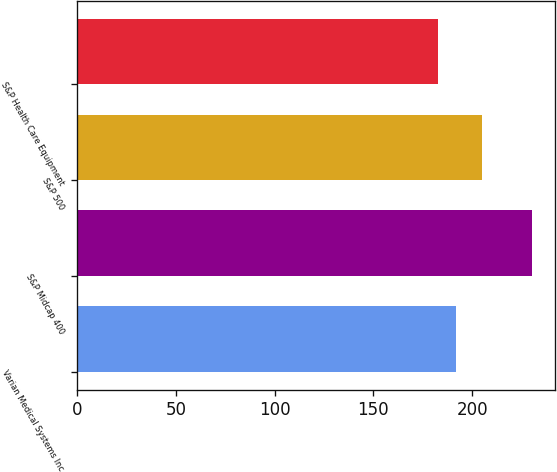Convert chart. <chart><loc_0><loc_0><loc_500><loc_500><bar_chart><fcel>Varian Medical Systems Inc<fcel>S&P Midcap 400<fcel>S&P 500<fcel>S&P Health Care Equipment<nl><fcel>191.8<fcel>230.45<fcel>205.13<fcel>182.68<nl></chart> 